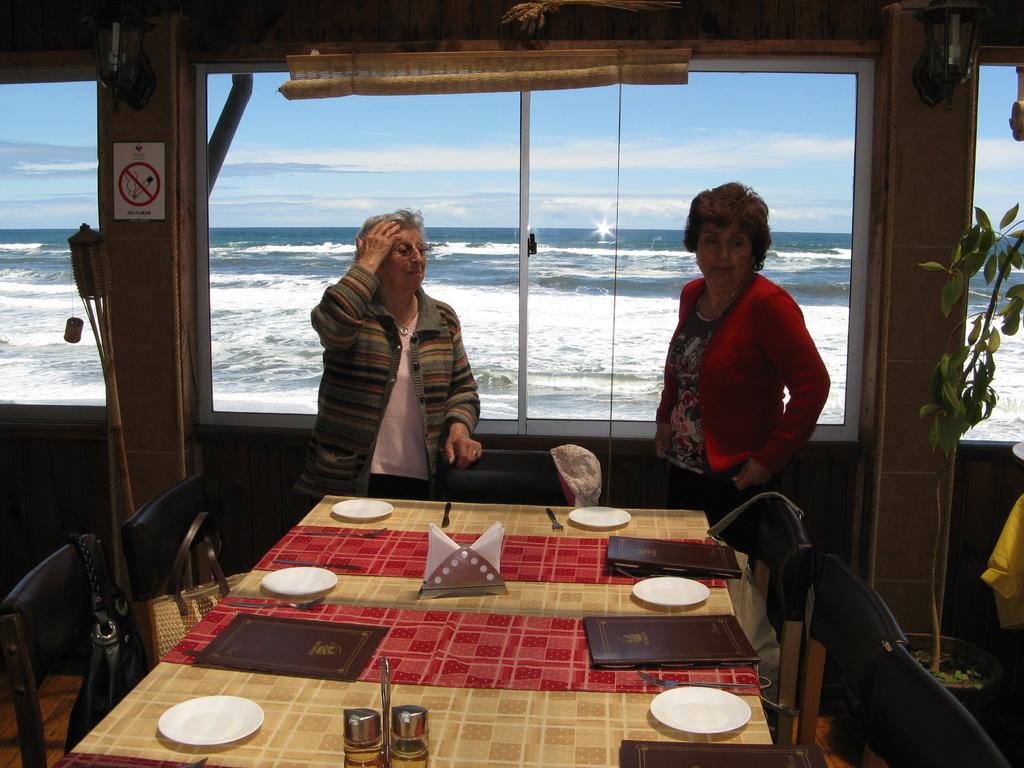Could you give a brief overview of what you see in this image? This image is clicked in a restaurant near the beach. In this image there are two women standing. In the front, there is a table on which there are plates, menus and tissues. In the background, there is a window from which we can see the ocean. To the right, there is a houseplant. 